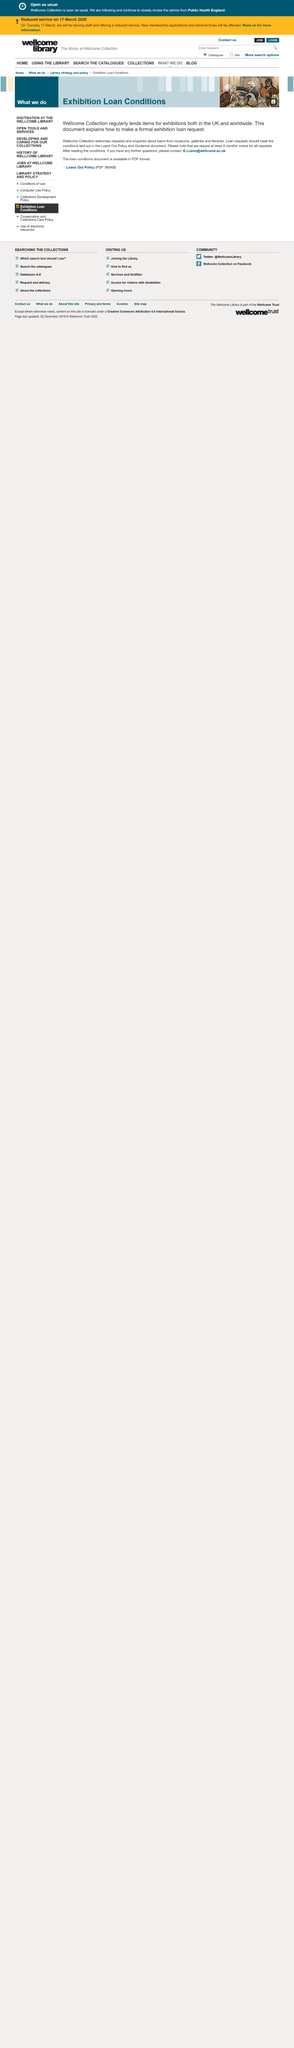Specify some key components in this picture. To request a loan at Wellcome Collection, you must follow the conditions outlined in the Loans Out Policy and Guidance document. The contact email for Wellcome Collection is [E.Loans@wellcome.ac.uk](mailto:E.Loans@wellcome.ac.uk). Wellcome Collection requires at least 9 months' notice for all loan requests. 